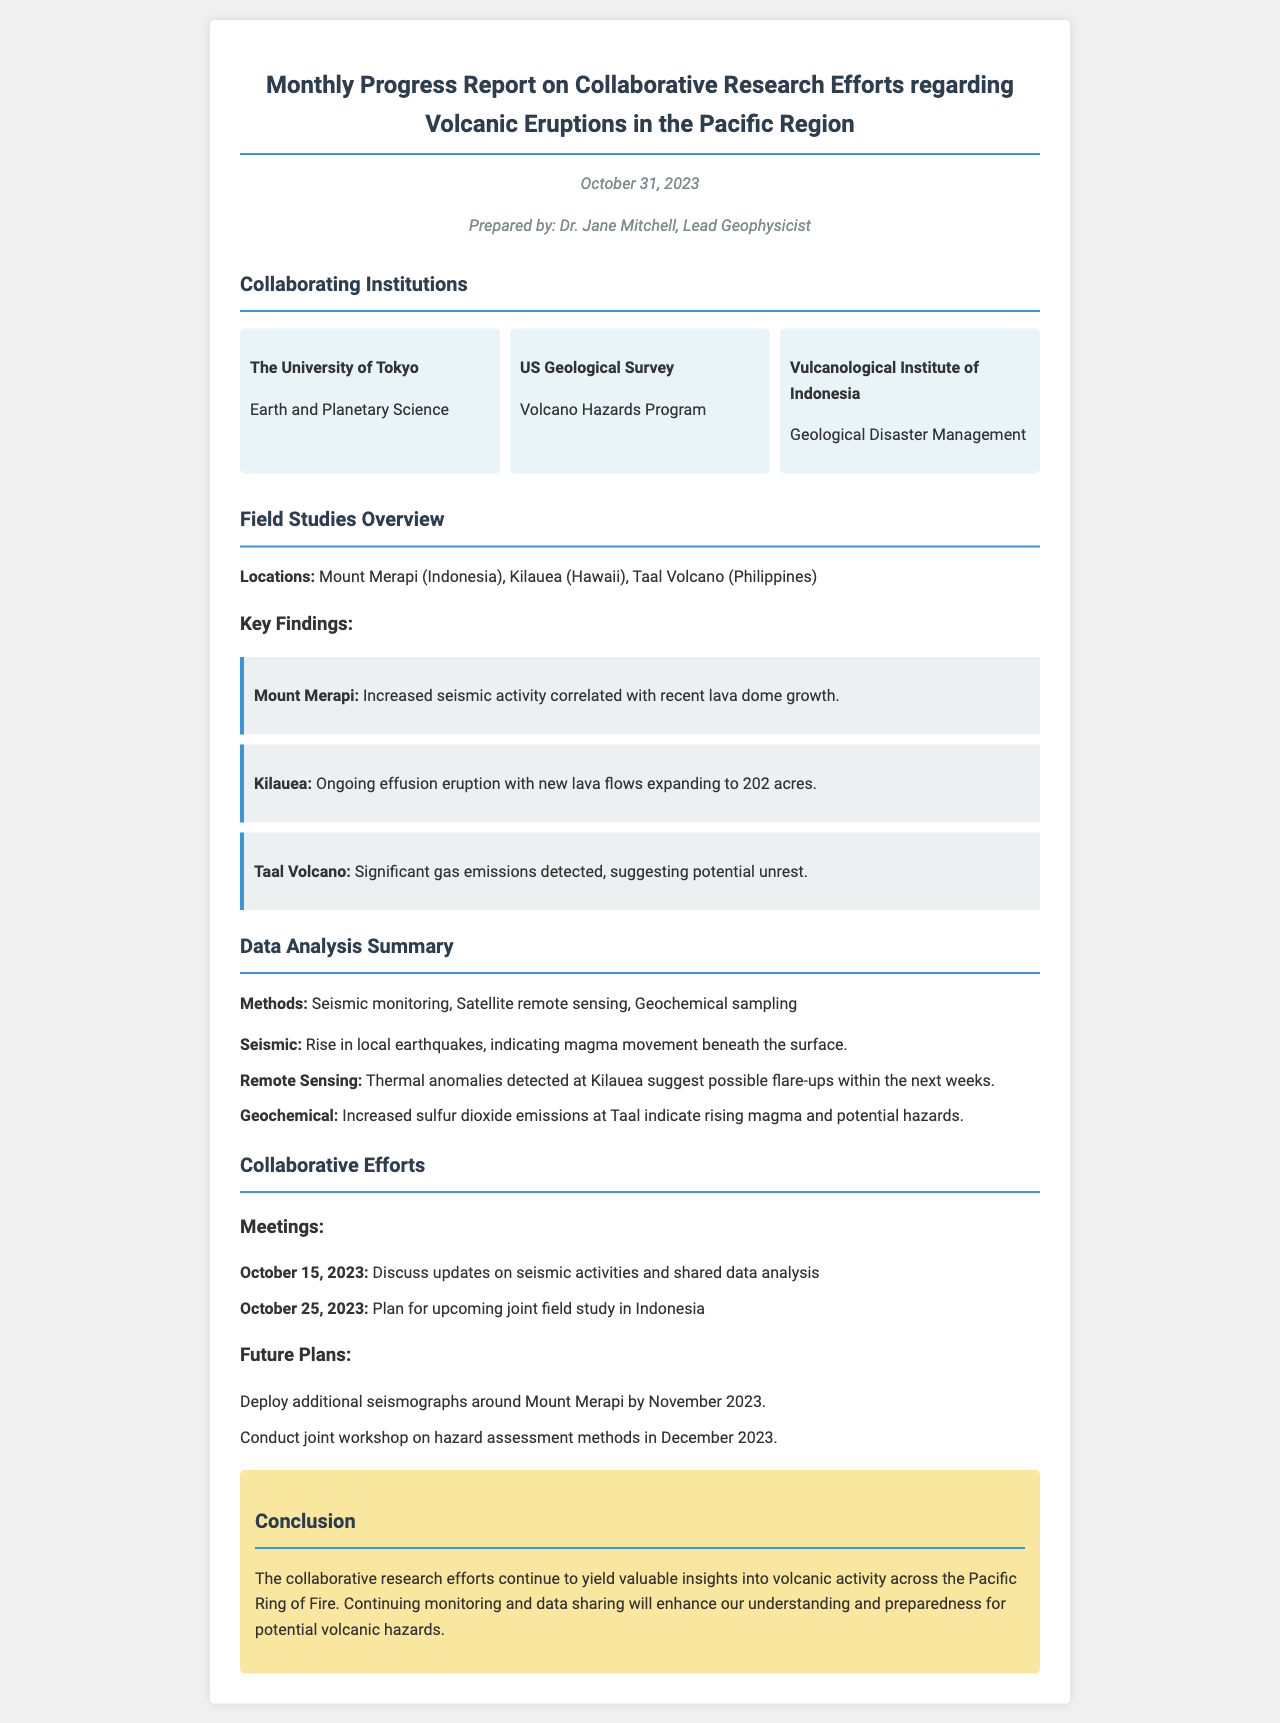What is the date of the report? The date of the report is mentioned at the top of the document, indicating when it was prepared.
Answer: October 31, 2023 Who is the prepared by? The name of the person who prepared the report is listed under the prepared by section.
Answer: Dr. Jane Mitchell Which institution focuses on Volcano Hazards Program? The document names specific institutions and their areas of focus, including the one specializing in volcano hazards.
Answer: US Geological Survey What is a key finding at Mount Merapi? Each location has key findings related to volcanic activity, and Mount Merapi has a specific key finding noted.
Answer: Increased seismic activity correlated with recent lava dome growth What method detects thermal anomalies at Kilauea? The methods utilized in data analysis provide insights into how certain phenomena are monitored.
Answer: Remote Sensing When was the meeting to discuss seismic activities held? The document outlines specific meetings along with their dates to detail collaborative efforts.
Answer: October 15, 2023 What future plan involves deploying seismographs? Future plans are outlined in the document, detailing actions that will be taken to improve research.
Answer: Deploy additional seismographs around Mount Merapi by November 2023 What location indicates significant gas emissions? The report highlights significant observations at the locations studied, particularly concerning gas emissions.
Answer: Taal Volcano What is the primary purpose of the collaborative research efforts? The conclusion provides an overarching goal for the research efforts detailed within the document.
Answer: Enhance understanding and preparedness for potential volcanic hazards 